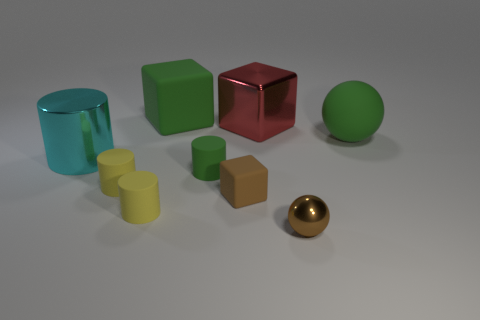What shape is the red metallic thing that is the same size as the cyan cylinder?
Make the answer very short. Cube. There is a metallic thing that is on the left side of the red shiny block; what color is it?
Offer a very short reply. Cyan. How many objects are either tiny objects to the right of the large metallic block or green objects that are in front of the large matte block?
Your answer should be compact. 3. Do the green rubber cylinder and the green sphere have the same size?
Offer a very short reply. No. How many spheres are either big brown shiny things or matte things?
Your answer should be very brief. 1. What number of objects are behind the large cyan metal thing and to the left of the brown shiny thing?
Your response must be concise. 2. Do the shiny cube and the matte cube right of the green matte block have the same size?
Your response must be concise. No. There is a yellow matte cylinder that is behind the block in front of the large rubber ball; is there a small object behind it?
Provide a short and direct response. Yes. The tiny green thing on the left side of the shiny object that is in front of the big cyan cylinder is made of what material?
Give a very brief answer. Rubber. There is a small object that is left of the brown matte cube and on the right side of the big green block; what is its material?
Offer a terse response. Rubber. 